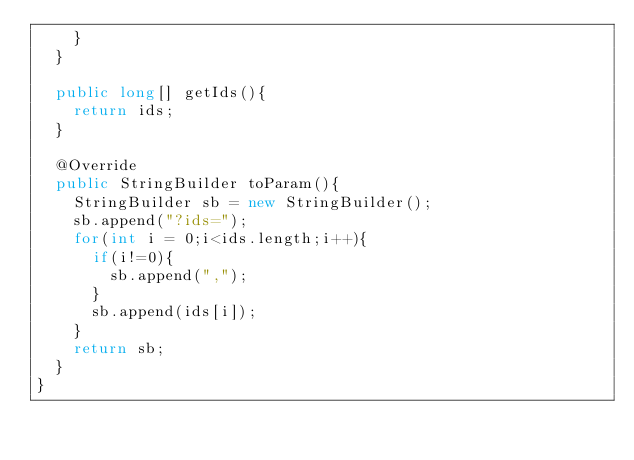<code> <loc_0><loc_0><loc_500><loc_500><_Java_>		}
	}

	public long[] getIds(){
		return ids;
	}

	@Override
	public StringBuilder toParam(){
		StringBuilder sb = new StringBuilder();
		sb.append("?ids=");
		for(int i = 0;i<ids.length;i++){
			if(i!=0){
				sb.append(",");
			}
			sb.append(ids[i]);
		}
		return sb;
	}
}
</code> 